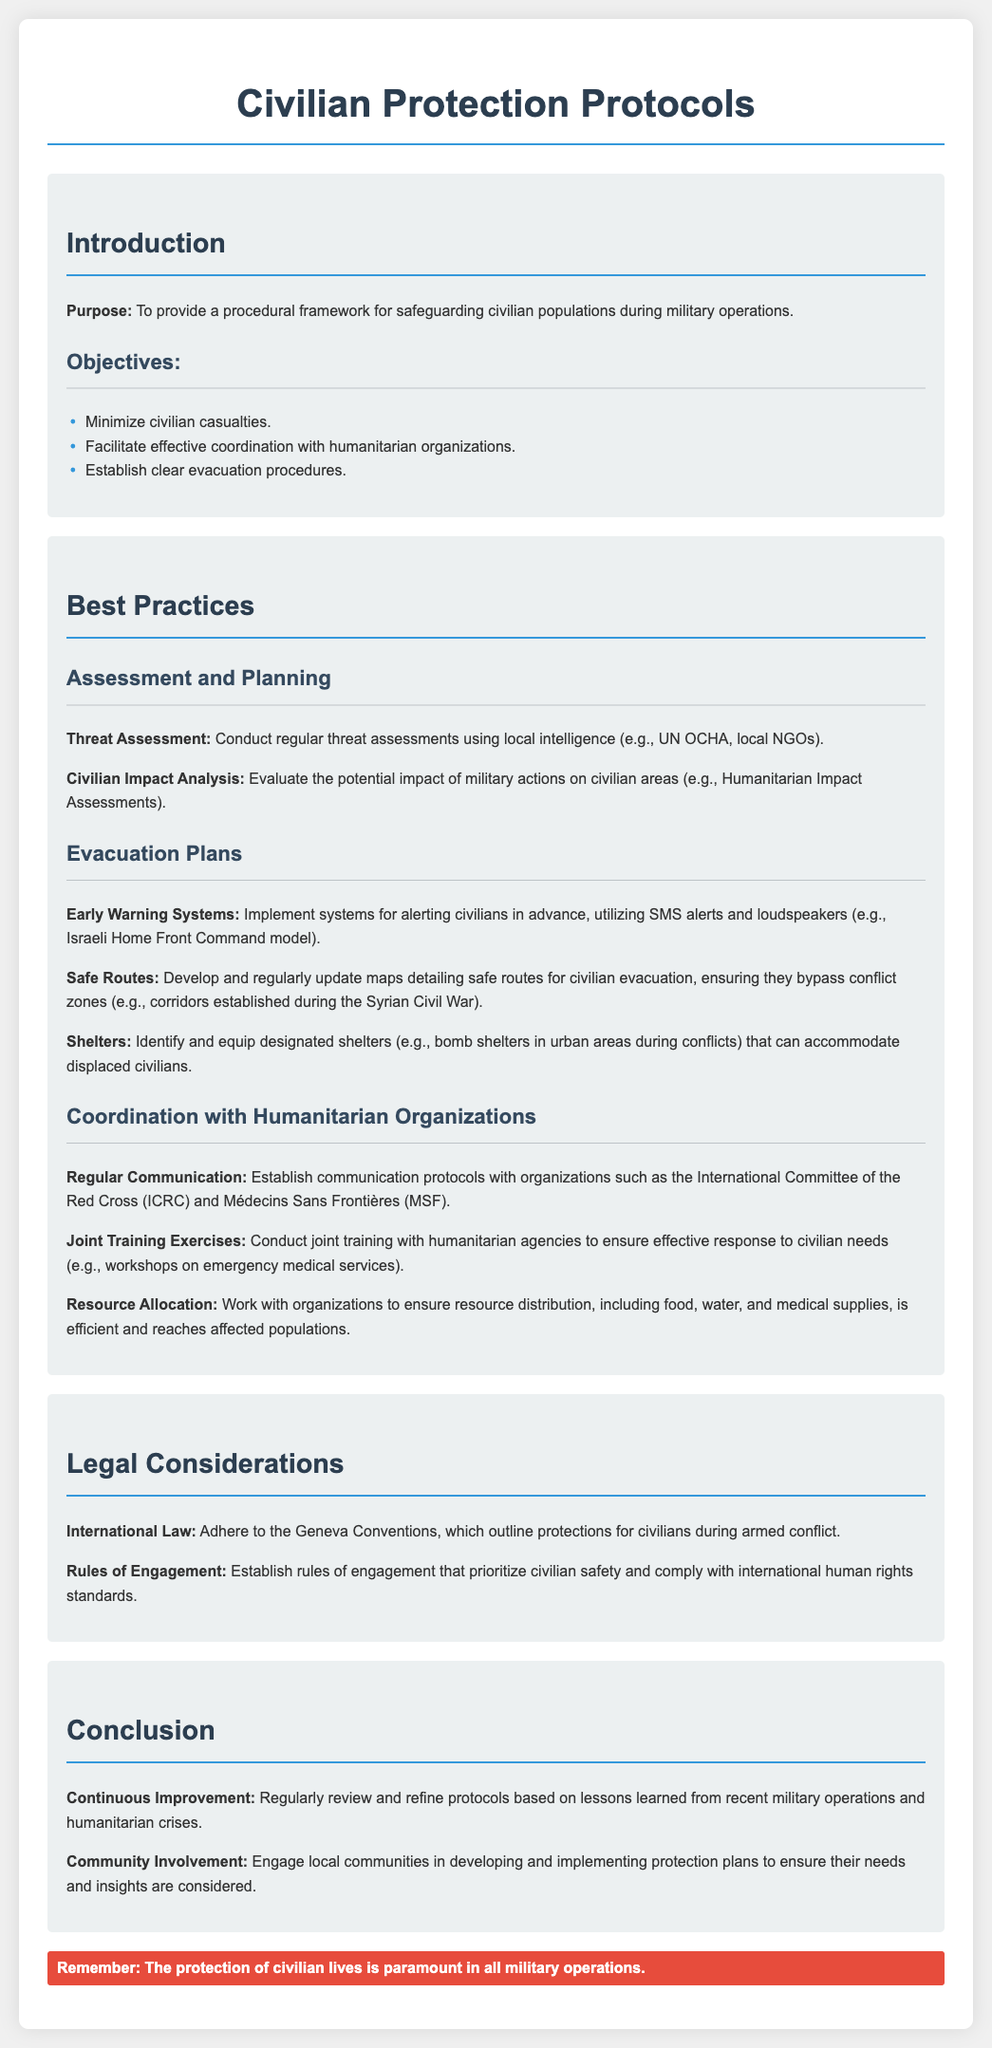what is the purpose of the manual? The purpose is to provide a procedural framework for safeguarding civilian populations during military operations.
Answer: procedural framework for safeguarding civilian populations during military operations what is the first objective listed? The first objective listed in the document is to minimize civilian casualties.
Answer: minimize civilian casualties which organizations are mentioned for coordination with humanitarian organizations? The document mentions the International Committee of the Red Cross (ICRC) and Médecins Sans Frontières (MSF) for coordination.
Answer: International Committee of the Red Cross (ICRC) and Médecins Sans Frontières (MSF) what system is suggested for alerting civilians in advance? The manual suggests implementing early warning systems utilizing SMS alerts and loudspeakers.
Answer: early warning systems utilizing SMS alerts and loudspeakers what legal document is referenced regarding civilian protections? The document references the Geneva Conventions regarding protections for civilians during armed conflict.
Answer: Geneva Conventions how should the protocols be improved over time? The protocols should be regularly reviewed and refined based on lessons learned from recent military operations and humanitarian crises.
Answer: regularly reviewed and refined based on lessons learned how many best practices are listed in the document? There are three main sections titled Best Practices, which include Assessment and Planning, Evacuation Plans, and Coordination.
Answer: three main sections what is a key highlight in the conclusion section? The highlight emphasizes that the protection of civilian lives is paramount in all military operations.
Answer: protection of civilian lives is paramount in all military operations 